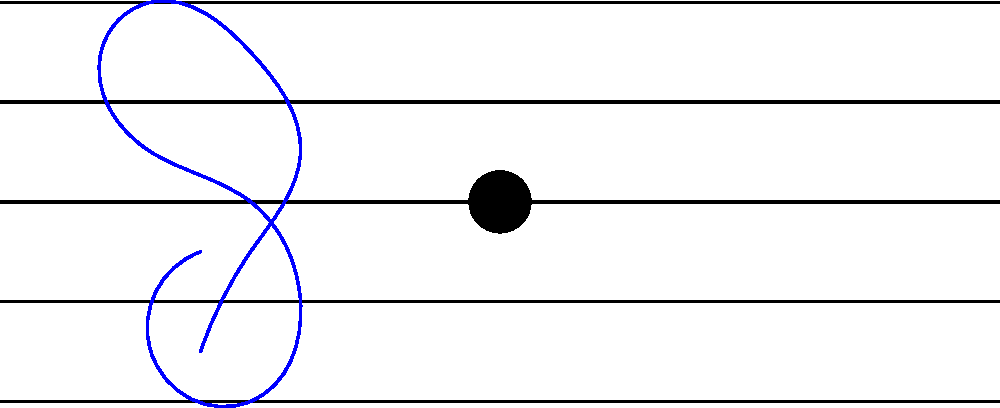In the given musical notation, a dashed line has been drawn. What type of symmetry does this line represent for the two quarter notes shown? To determine the type of symmetry represented by the dashed line, we need to analyze the position of the quarter notes relative to this line:

1. Observe that the dashed line is placed vertically between the two quarter notes.

2. Check the distance of each note from the dashed line:
   - The first note is approximately 10 units to the left of the line.
   - The second note is approximately 10 units to the right of the line.

3. Compare the vertical positions of the notes:
   - The first note is on the fourth line from the bottom.
   - The second note is on the third line from the bottom.

4. Consider the direction of the note stems:
   - The first note's stem points upward.
   - The second note's stem also points upward.

5. Analyze what would happen if we "folded" the image along the dashed line:
   - The notes would not align perfectly.
   - Their horizontal positions would match, but their vertical positions and stem directions would not.

6. Recall the definition of reflective symmetry:
   - In reflective symmetry, each point on one side of the line of symmetry has a corresponding point on the other side, equidistant from the line.

7. Conclude that this is not reflective symmetry, as the notes are not perfect mirror images of each other across the dashed line.

8. Consider the definition of translational symmetry:
   - In translational symmetry, a shape is moved in a specific direction without rotation or reflection.

9. Observe that the second note appears to be a translation of the first note:
   - It is moved horizontally to the right.
   - It is moved slightly downward vertically.

Therefore, the dashed line represents the axis of translational symmetry between the two quarter notes.
Answer: Translational symmetry 